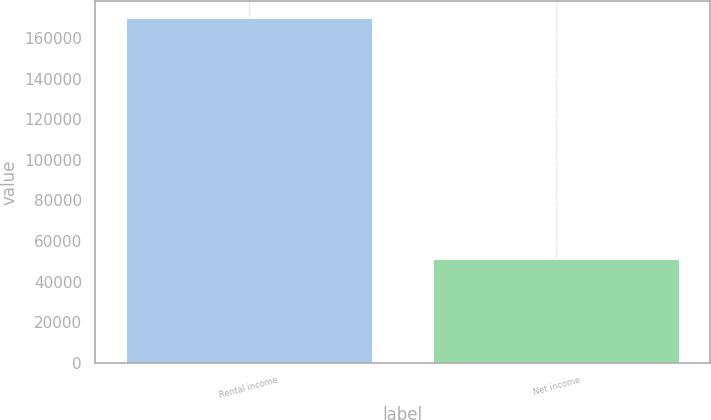Convert chart to OTSL. <chart><loc_0><loc_0><loc_500><loc_500><bar_chart><fcel>Rental income<fcel>Net income<nl><fcel>169683<fcel>51013<nl></chart> 